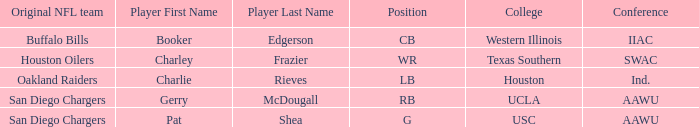What player's original team are the Oakland Raiders? Charlie Rieves Category:Articles with hCards. 